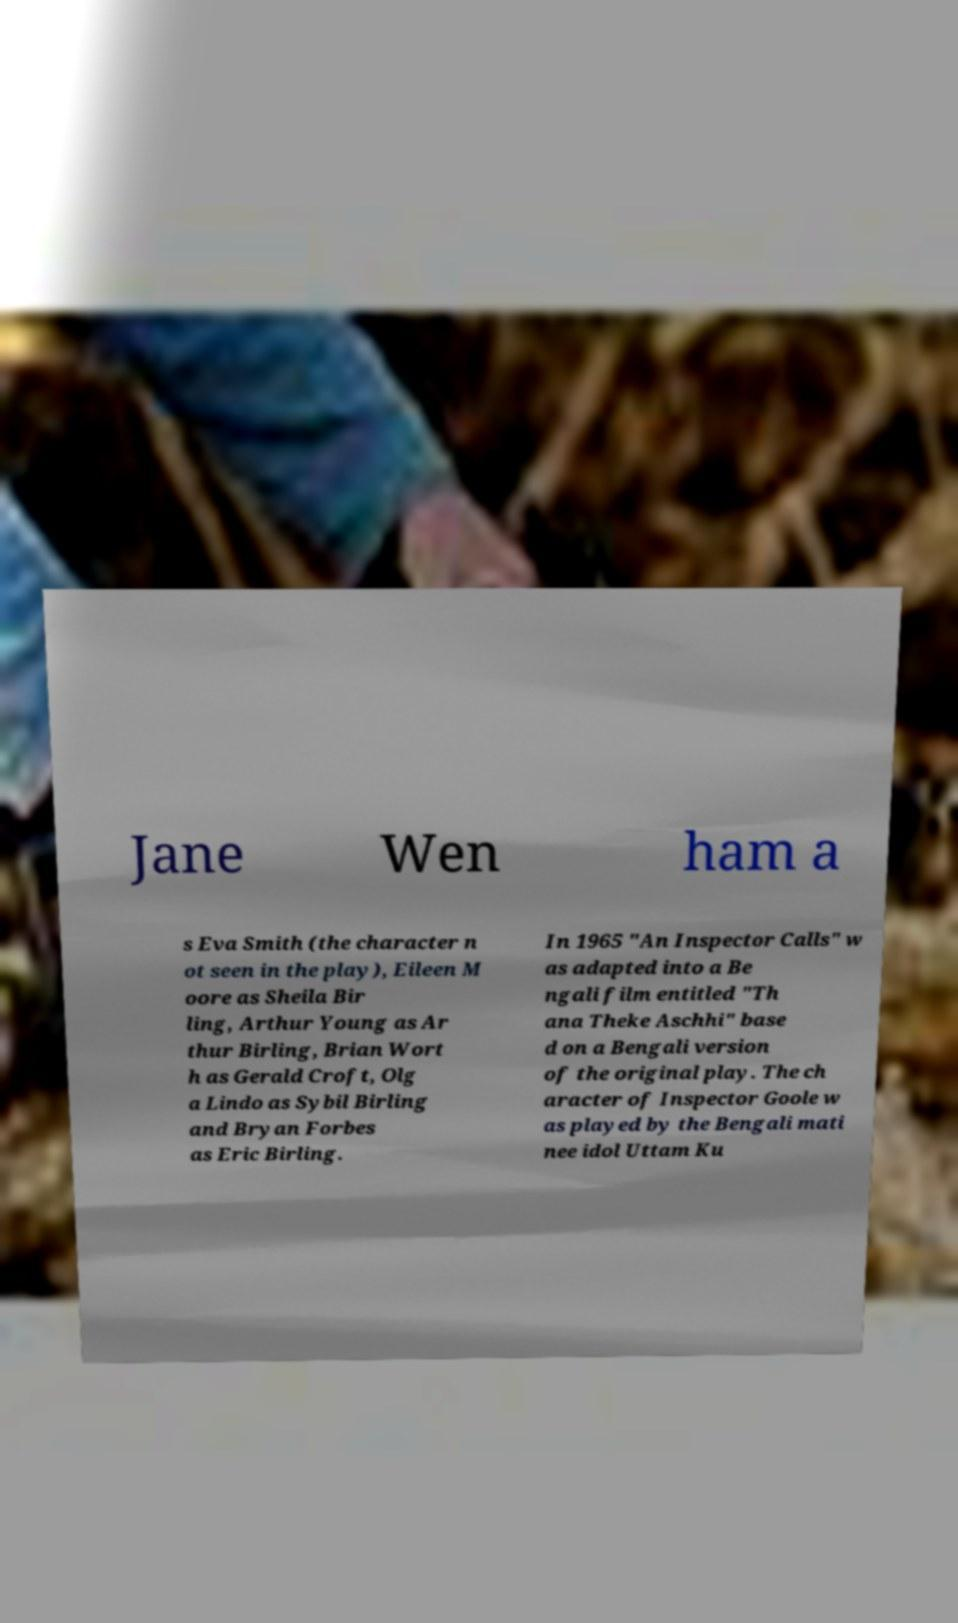Please read and relay the text visible in this image. What does it say? Jane Wen ham a s Eva Smith (the character n ot seen in the play), Eileen M oore as Sheila Bir ling, Arthur Young as Ar thur Birling, Brian Wort h as Gerald Croft, Olg a Lindo as Sybil Birling and Bryan Forbes as Eric Birling. In 1965 "An Inspector Calls" w as adapted into a Be ngali film entitled "Th ana Theke Aschhi" base d on a Bengali version of the original play. The ch aracter of Inspector Goole w as played by the Bengali mati nee idol Uttam Ku 